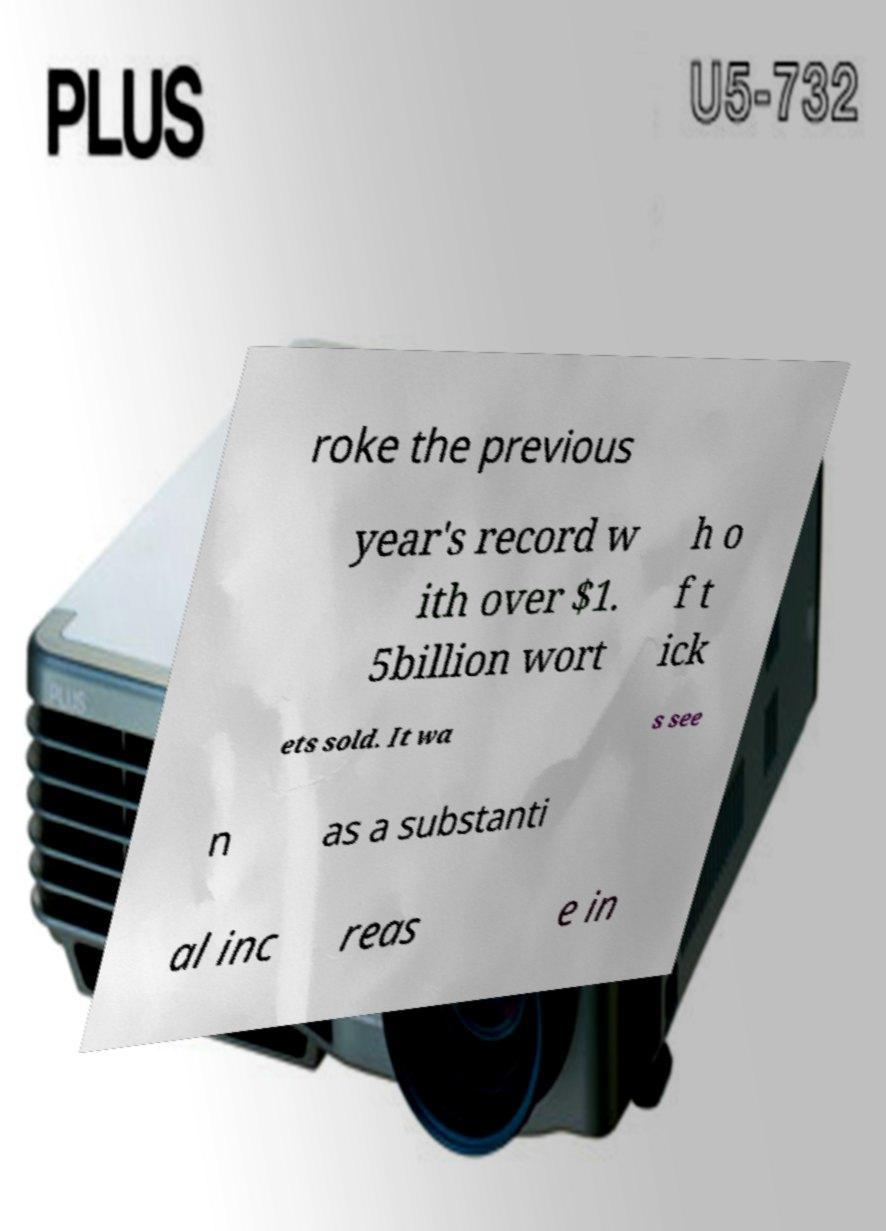Could you extract and type out the text from this image? roke the previous year's record w ith over $1. 5billion wort h o f t ick ets sold. It wa s see n as a substanti al inc reas e in 